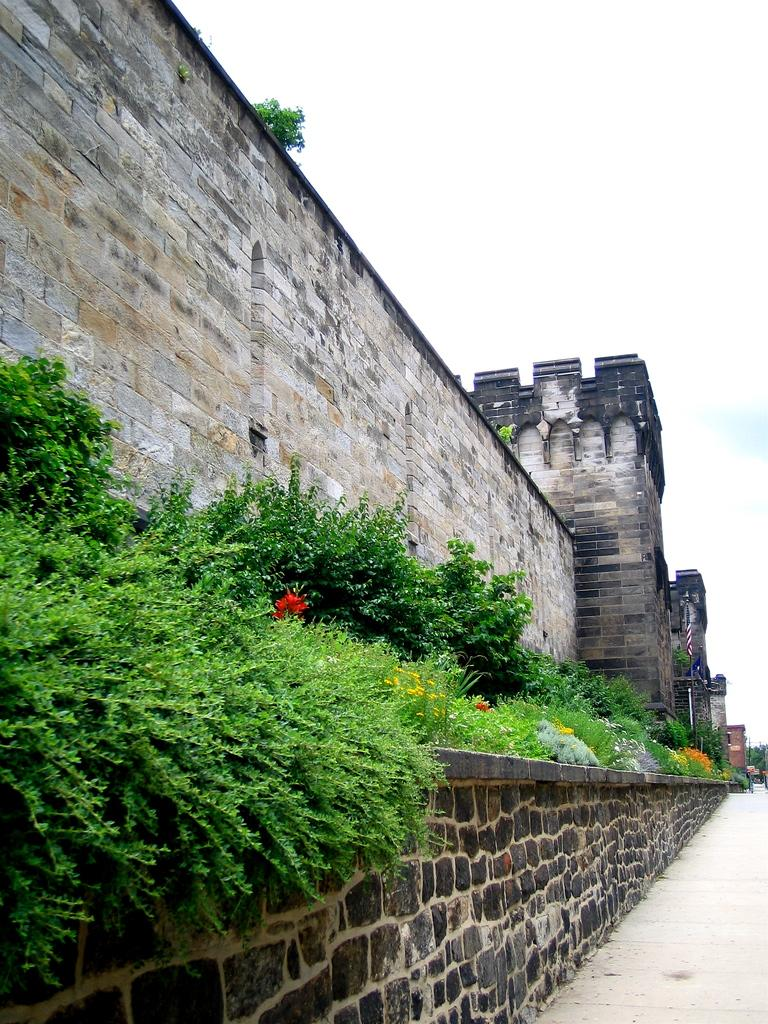What type of living organisms can be seen in the image? Plants and flowers are visible in the image. What is the background of the image composed of? There is a wall, a flag, buildings, and the sky visible in the background of the image. What type of porter is carrying the plants in the image? There is no porter carrying plants in the image; the plants are stationary. Can you see any mist in the image? There is no mist visible in the image. 